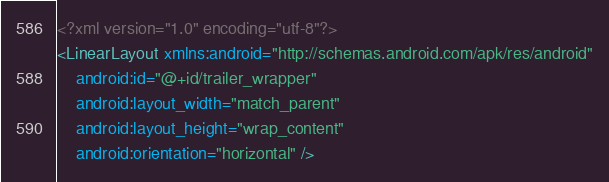Convert code to text. <code><loc_0><loc_0><loc_500><loc_500><_XML_><?xml version="1.0" encoding="utf-8"?>
<LinearLayout xmlns:android="http://schemas.android.com/apk/res/android"
    android:id="@+id/trailer_wrapper"
    android:layout_width="match_parent"
    android:layout_height="wrap_content"
    android:orientation="horizontal" />

</code> 